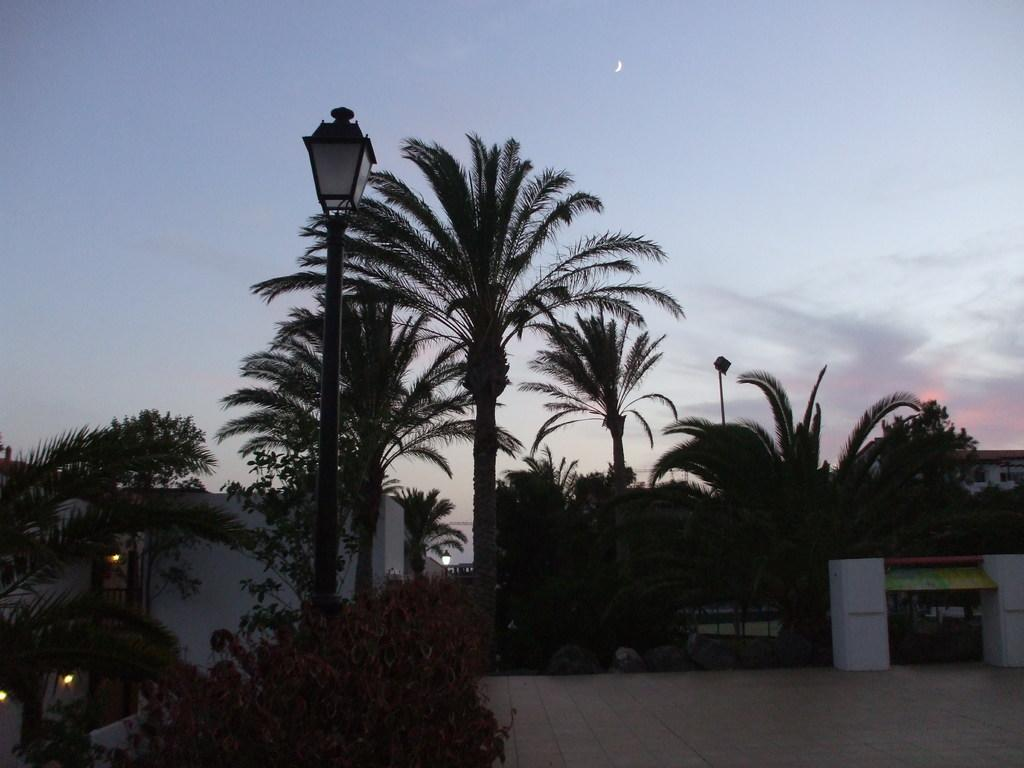What type of vegetation can be seen in the image? There are plants and trees in the image. What structures are present in the image? There are poles, lights, a floor, pillars, and houses in the image. What is visible in the background of the image? There is sky visible in the background of the image, with clouds present. What type of pain is being experienced by the person in the image? There is no person present in the image, so it is not possible to determine if anyone is experiencing pain. How does the lift function in the image? There is no lift present in the image, so it is not possible to describe its function. 